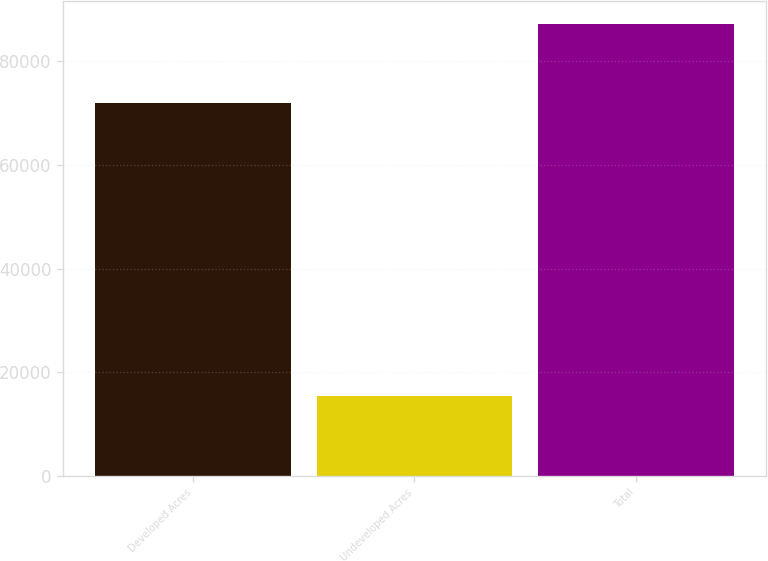Convert chart to OTSL. <chart><loc_0><loc_0><loc_500><loc_500><bar_chart><fcel>Developed Acres<fcel>Undeveloped Acres<fcel>Total<nl><fcel>71919<fcel>15369<fcel>87288<nl></chart> 